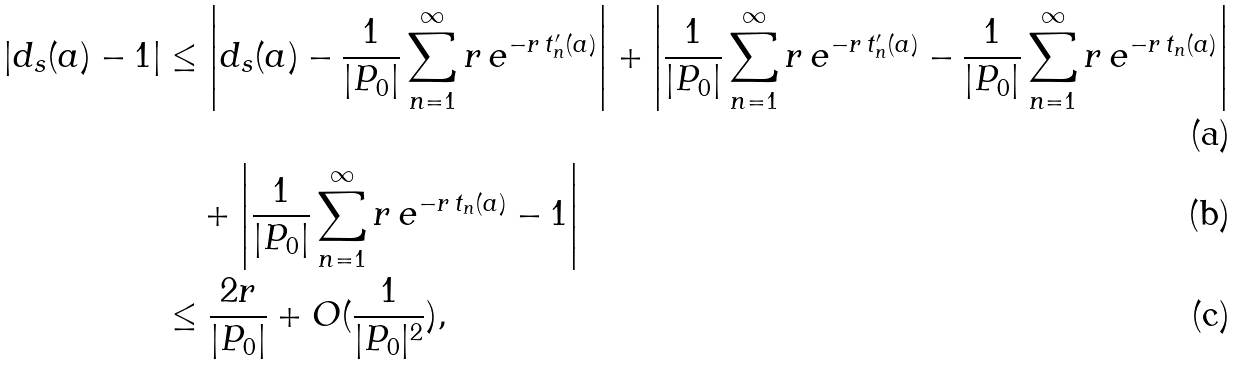Convert formula to latex. <formula><loc_0><loc_0><loc_500><loc_500>\left | d _ { s } ( a ) - 1 \right | & \leq \left | d _ { s } ( a ) - \frac { 1 } { | P _ { 0 } | } \sum _ { n = 1 } ^ { \infty } r \, e ^ { - r \, t ^ { \prime } _ { n } ( a ) } \right | + \left | \frac { 1 } { | P _ { 0 } | } \sum _ { n = 1 } ^ { \infty } r \, e ^ { - r \, t _ { n } ^ { \prime } ( a ) } - \frac { 1 } { | P _ { 0 } | } \sum _ { n = 1 } ^ { \infty } r \, e ^ { - r \, t _ { n } ( a ) } \right | \\ & \quad + \left | \frac { 1 } { | P _ { 0 } | } \sum _ { n = 1 } ^ { \infty } r \, e ^ { - r \, t _ { n } ( a ) } - 1 \right | \\ & \leq \frac { 2 r } { | P _ { 0 } | } + O ( \frac { 1 } { | P _ { 0 } | ^ { 2 } } ) ,</formula> 